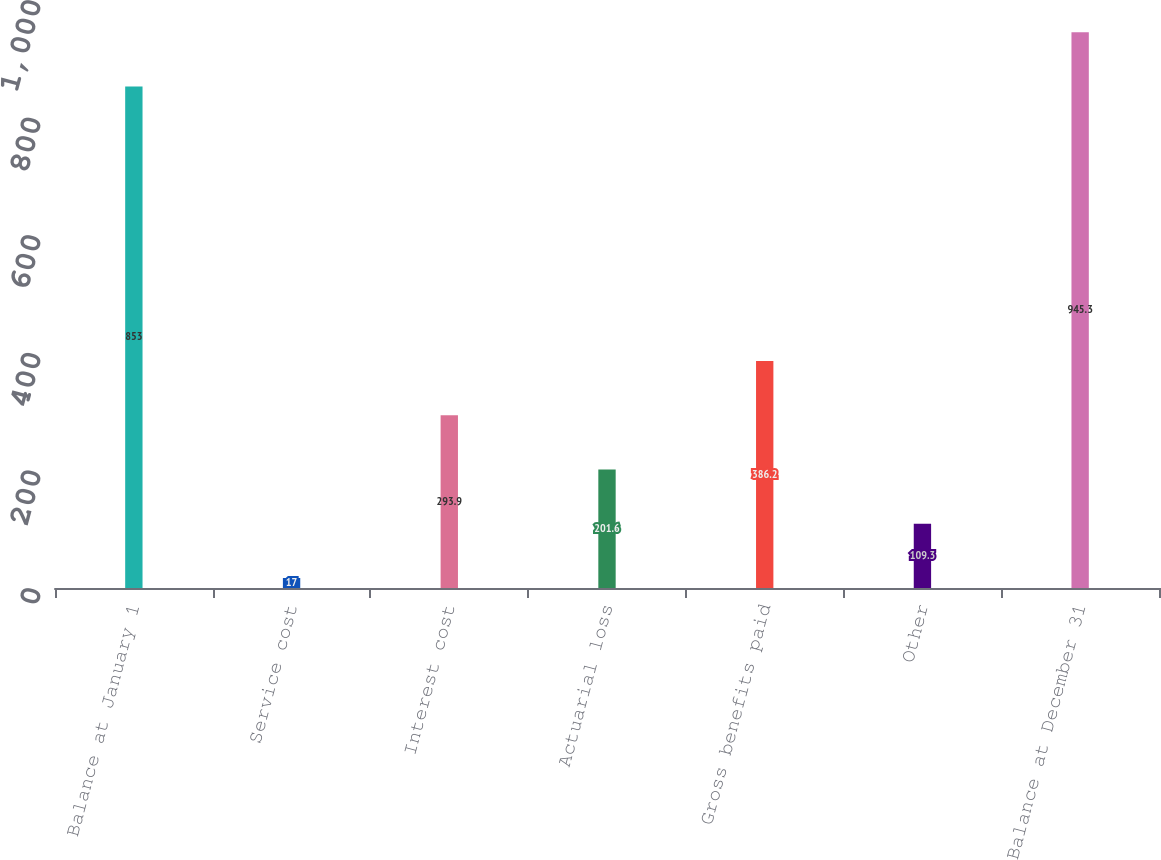Convert chart. <chart><loc_0><loc_0><loc_500><loc_500><bar_chart><fcel>Balance at January 1<fcel>Service cost<fcel>Interest cost<fcel>Actuarial loss<fcel>Gross benefits paid<fcel>Other<fcel>Balance at December 31<nl><fcel>853<fcel>17<fcel>293.9<fcel>201.6<fcel>386.2<fcel>109.3<fcel>945.3<nl></chart> 